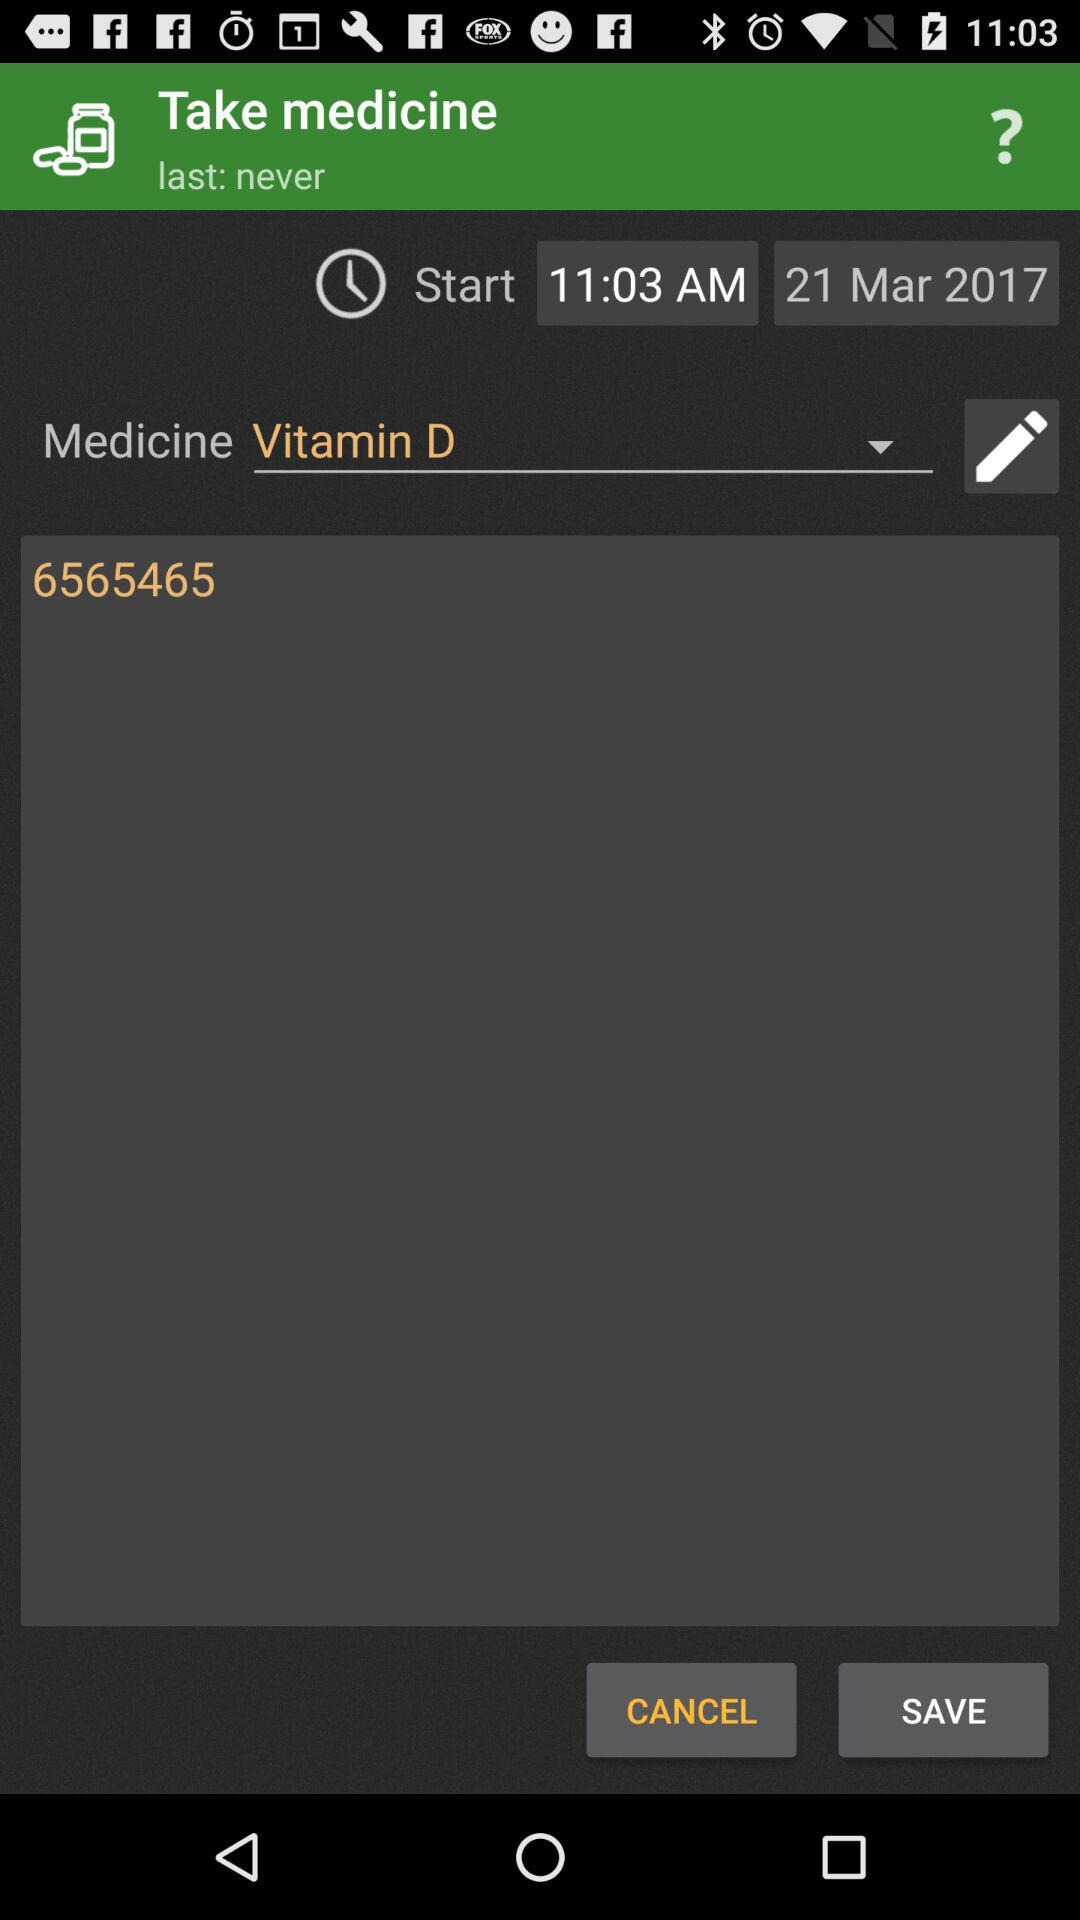What is the start time of the medicine?
Answer the question using a single word or phrase. 11:03 AM 